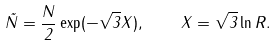Convert formula to latex. <formula><loc_0><loc_0><loc_500><loc_500>\tilde { N } = \frac { N } { 2 } \exp ( - \sqrt { 3 } X ) , \quad X = \sqrt { 3 } \ln R .</formula> 